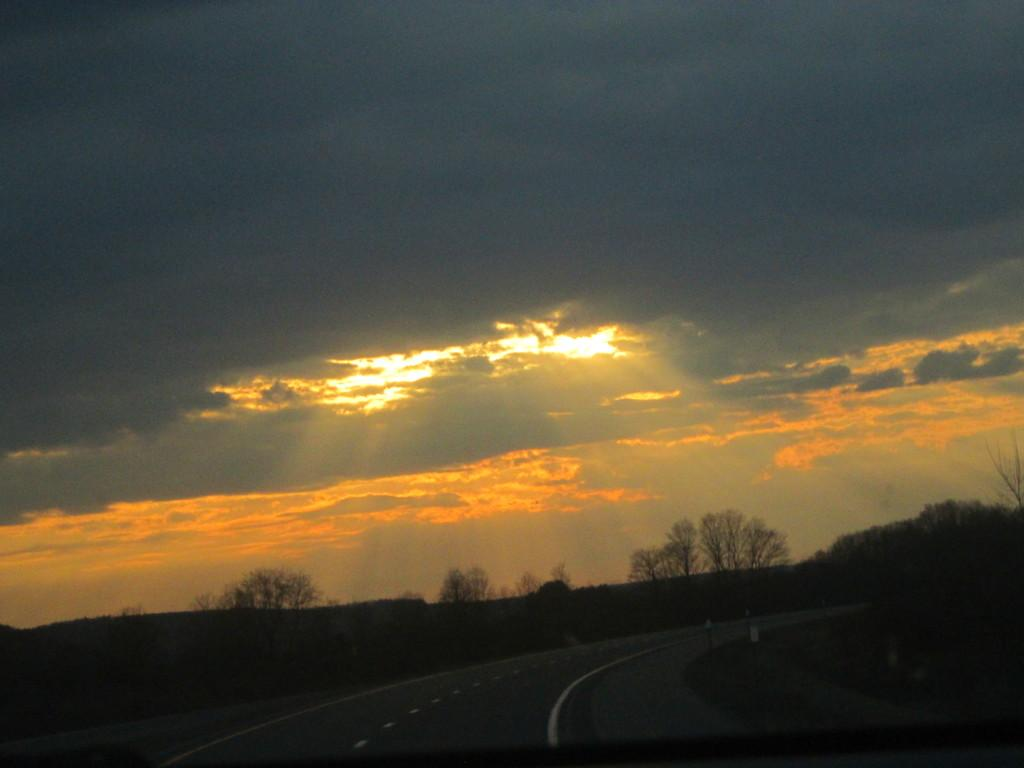What is the setting of the image? The image is an outside view. What can be seen at the bottom of the image? There is a road at the bottom of the image. What type of vegetation is present on both sides of the road? There are trees on both sides of the road. What is visible at the top of the image? The sky is visible at the top of the image. What can be observed in the sky? Clouds are present in the sky. What type of stretch is visible on the road in the image? There is no stretch visible on the road in the image; it is a regular road with trees on both sides. What type of board is being used to cover the trees in the image? There is no board being used to cover the trees in the image; the trees are visible and not obstructed. 